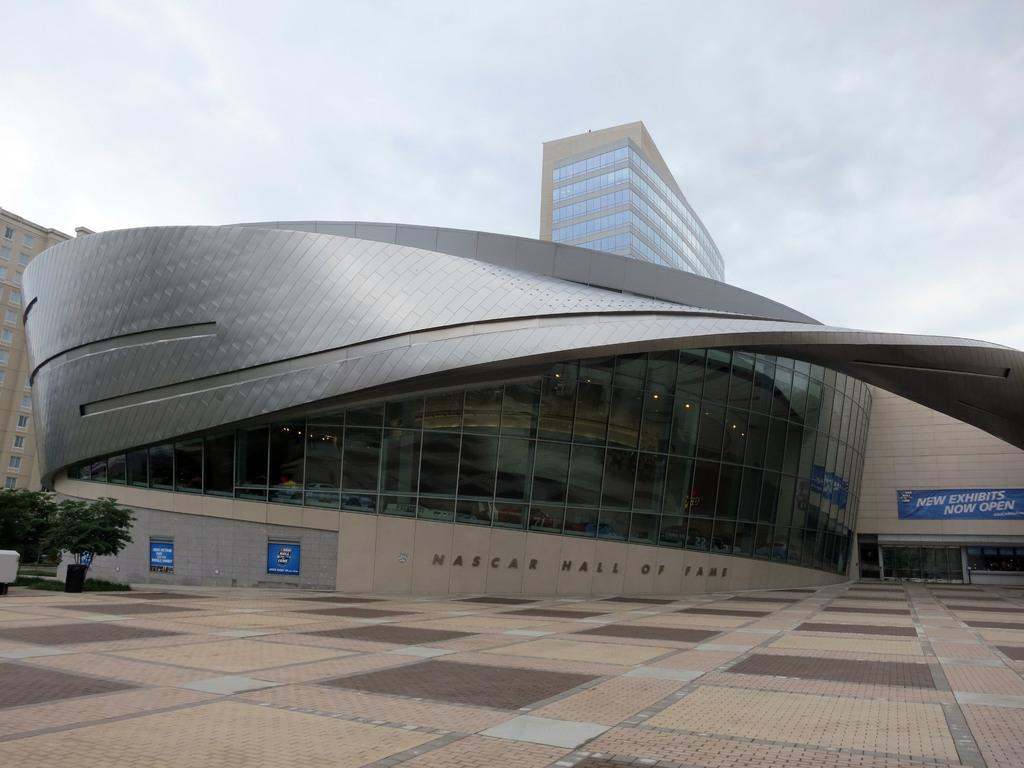<image>
Summarize the visual content of the image. the outside view of the nascar hall of fame 